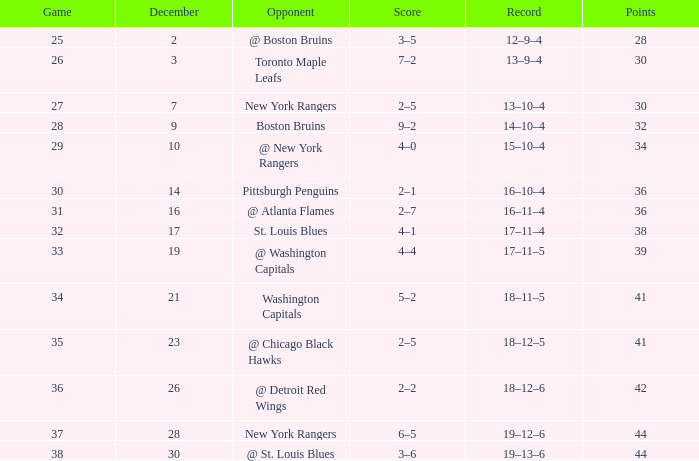Which Score has a Game larger than 32, and Points smaller than 42, and a December larger than 19, and a Record of 18–12–5? 2–5. 